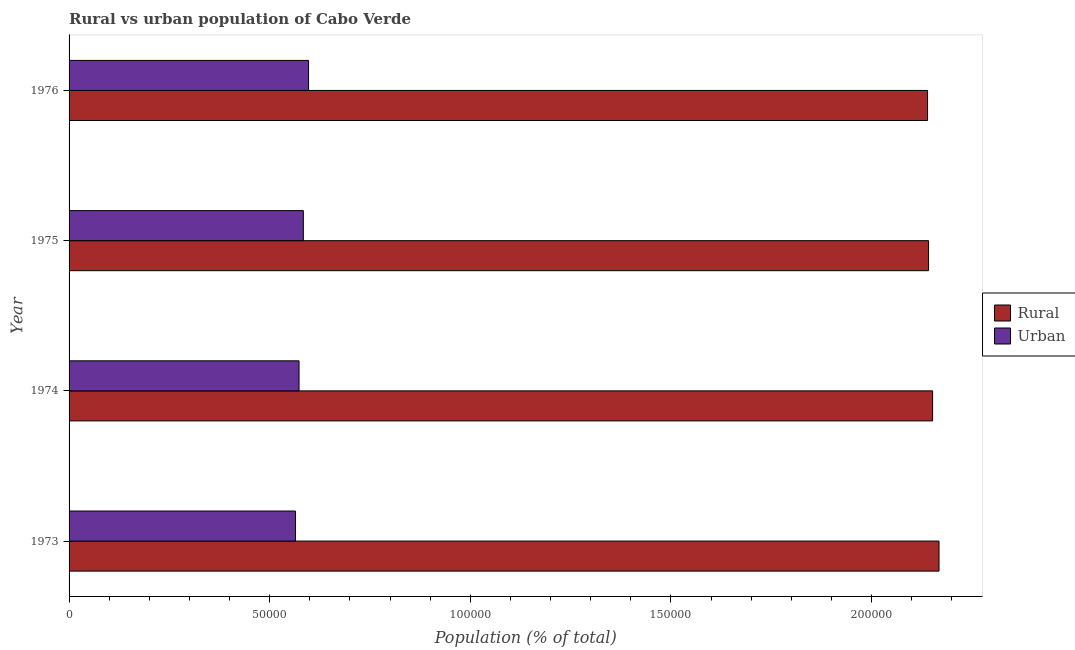How many different coloured bars are there?
Ensure brevity in your answer.  2. How many groups of bars are there?
Provide a short and direct response. 4. How many bars are there on the 2nd tick from the bottom?
Ensure brevity in your answer.  2. What is the label of the 4th group of bars from the top?
Offer a very short reply. 1973. What is the rural population density in 1975?
Offer a very short reply. 2.14e+05. Across all years, what is the maximum urban population density?
Offer a very short reply. 5.97e+04. Across all years, what is the minimum rural population density?
Offer a terse response. 2.14e+05. In which year was the urban population density maximum?
Provide a succinct answer. 1976. In which year was the urban population density minimum?
Give a very brief answer. 1973. What is the total urban population density in the graph?
Give a very brief answer. 2.32e+05. What is the difference between the urban population density in 1973 and that in 1974?
Give a very brief answer. -896. What is the difference between the rural population density in 1976 and the urban population density in 1975?
Make the answer very short. 1.56e+05. What is the average urban population density per year?
Your response must be concise. 5.79e+04. In the year 1975, what is the difference between the urban population density and rural population density?
Your answer should be compact. -1.56e+05. What is the ratio of the urban population density in 1973 to that in 1974?
Your answer should be compact. 0.98. Is the difference between the rural population density in 1973 and 1976 greater than the difference between the urban population density in 1973 and 1976?
Provide a short and direct response. Yes. What is the difference between the highest and the second highest rural population density?
Offer a terse response. 1598. What is the difference between the highest and the lowest urban population density?
Offer a terse response. 3268. In how many years, is the urban population density greater than the average urban population density taken over all years?
Make the answer very short. 2. What does the 1st bar from the top in 1973 represents?
Provide a short and direct response. Urban. What does the 1st bar from the bottom in 1973 represents?
Your response must be concise. Rural. What is the title of the graph?
Provide a succinct answer. Rural vs urban population of Cabo Verde. Does "Female" appear as one of the legend labels in the graph?
Provide a succinct answer. No. What is the label or title of the X-axis?
Your answer should be compact. Population (% of total). What is the label or title of the Y-axis?
Offer a terse response. Year. What is the Population (% of total) in Rural in 1973?
Provide a succinct answer. 2.17e+05. What is the Population (% of total) in Urban in 1973?
Your response must be concise. 5.64e+04. What is the Population (% of total) in Rural in 1974?
Provide a short and direct response. 2.15e+05. What is the Population (% of total) in Urban in 1974?
Make the answer very short. 5.73e+04. What is the Population (% of total) in Rural in 1975?
Your answer should be very brief. 2.14e+05. What is the Population (% of total) in Urban in 1975?
Provide a short and direct response. 5.84e+04. What is the Population (% of total) in Rural in 1976?
Your answer should be very brief. 2.14e+05. What is the Population (% of total) of Urban in 1976?
Offer a terse response. 5.97e+04. Across all years, what is the maximum Population (% of total) of Rural?
Keep it short and to the point. 2.17e+05. Across all years, what is the maximum Population (% of total) of Urban?
Provide a short and direct response. 5.97e+04. Across all years, what is the minimum Population (% of total) in Rural?
Your answer should be very brief. 2.14e+05. Across all years, what is the minimum Population (% of total) of Urban?
Keep it short and to the point. 5.64e+04. What is the total Population (% of total) in Rural in the graph?
Give a very brief answer. 8.60e+05. What is the total Population (% of total) in Urban in the graph?
Provide a succinct answer. 2.32e+05. What is the difference between the Population (% of total) of Rural in 1973 and that in 1974?
Provide a short and direct response. 1598. What is the difference between the Population (% of total) of Urban in 1973 and that in 1974?
Make the answer very short. -896. What is the difference between the Population (% of total) in Rural in 1973 and that in 1975?
Ensure brevity in your answer.  2604. What is the difference between the Population (% of total) in Urban in 1973 and that in 1975?
Provide a succinct answer. -1968. What is the difference between the Population (% of total) in Rural in 1973 and that in 1976?
Give a very brief answer. 2854. What is the difference between the Population (% of total) in Urban in 1973 and that in 1976?
Provide a succinct answer. -3268. What is the difference between the Population (% of total) of Rural in 1974 and that in 1975?
Provide a short and direct response. 1006. What is the difference between the Population (% of total) in Urban in 1974 and that in 1975?
Make the answer very short. -1072. What is the difference between the Population (% of total) of Rural in 1974 and that in 1976?
Make the answer very short. 1256. What is the difference between the Population (% of total) of Urban in 1974 and that in 1976?
Provide a succinct answer. -2372. What is the difference between the Population (% of total) in Rural in 1975 and that in 1976?
Ensure brevity in your answer.  250. What is the difference between the Population (% of total) of Urban in 1975 and that in 1976?
Your answer should be compact. -1300. What is the difference between the Population (% of total) of Rural in 1973 and the Population (% of total) of Urban in 1974?
Provide a succinct answer. 1.59e+05. What is the difference between the Population (% of total) of Rural in 1973 and the Population (% of total) of Urban in 1975?
Keep it short and to the point. 1.58e+05. What is the difference between the Population (% of total) of Rural in 1973 and the Population (% of total) of Urban in 1976?
Provide a short and direct response. 1.57e+05. What is the difference between the Population (% of total) of Rural in 1974 and the Population (% of total) of Urban in 1975?
Your answer should be very brief. 1.57e+05. What is the difference between the Population (% of total) in Rural in 1974 and the Population (% of total) in Urban in 1976?
Make the answer very short. 1.56e+05. What is the difference between the Population (% of total) of Rural in 1975 and the Population (% of total) of Urban in 1976?
Offer a very short reply. 1.55e+05. What is the average Population (% of total) of Rural per year?
Your answer should be compact. 2.15e+05. What is the average Population (% of total) in Urban per year?
Offer a very short reply. 5.79e+04. In the year 1973, what is the difference between the Population (% of total) of Rural and Population (% of total) of Urban?
Ensure brevity in your answer.  1.60e+05. In the year 1974, what is the difference between the Population (% of total) in Rural and Population (% of total) in Urban?
Your answer should be very brief. 1.58e+05. In the year 1975, what is the difference between the Population (% of total) in Rural and Population (% of total) in Urban?
Make the answer very short. 1.56e+05. In the year 1976, what is the difference between the Population (% of total) in Rural and Population (% of total) in Urban?
Your answer should be compact. 1.54e+05. What is the ratio of the Population (% of total) in Rural in 1973 to that in 1974?
Your answer should be compact. 1.01. What is the ratio of the Population (% of total) in Urban in 1973 to that in 1974?
Your answer should be very brief. 0.98. What is the ratio of the Population (% of total) of Rural in 1973 to that in 1975?
Make the answer very short. 1.01. What is the ratio of the Population (% of total) of Urban in 1973 to that in 1975?
Give a very brief answer. 0.97. What is the ratio of the Population (% of total) of Rural in 1973 to that in 1976?
Offer a very short reply. 1.01. What is the ratio of the Population (% of total) in Urban in 1973 to that in 1976?
Give a very brief answer. 0.95. What is the ratio of the Population (% of total) in Rural in 1974 to that in 1975?
Provide a short and direct response. 1. What is the ratio of the Population (% of total) in Urban in 1974 to that in 1975?
Your answer should be very brief. 0.98. What is the ratio of the Population (% of total) in Rural in 1974 to that in 1976?
Offer a terse response. 1.01. What is the ratio of the Population (% of total) of Urban in 1974 to that in 1976?
Offer a very short reply. 0.96. What is the ratio of the Population (% of total) in Rural in 1975 to that in 1976?
Offer a very short reply. 1. What is the ratio of the Population (% of total) in Urban in 1975 to that in 1976?
Keep it short and to the point. 0.98. What is the difference between the highest and the second highest Population (% of total) of Rural?
Offer a very short reply. 1598. What is the difference between the highest and the second highest Population (% of total) in Urban?
Your answer should be compact. 1300. What is the difference between the highest and the lowest Population (% of total) of Rural?
Your answer should be very brief. 2854. What is the difference between the highest and the lowest Population (% of total) of Urban?
Offer a terse response. 3268. 